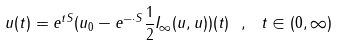Convert formula to latex. <formula><loc_0><loc_0><loc_500><loc_500>u ( t ) = e ^ { t S } ( u _ { 0 } - e ^ { - \cdot S } \frac { 1 } { 2 } I _ { \infty } ( u , u ) ) ( t ) \ , \ t \in ( 0 , \infty )</formula> 